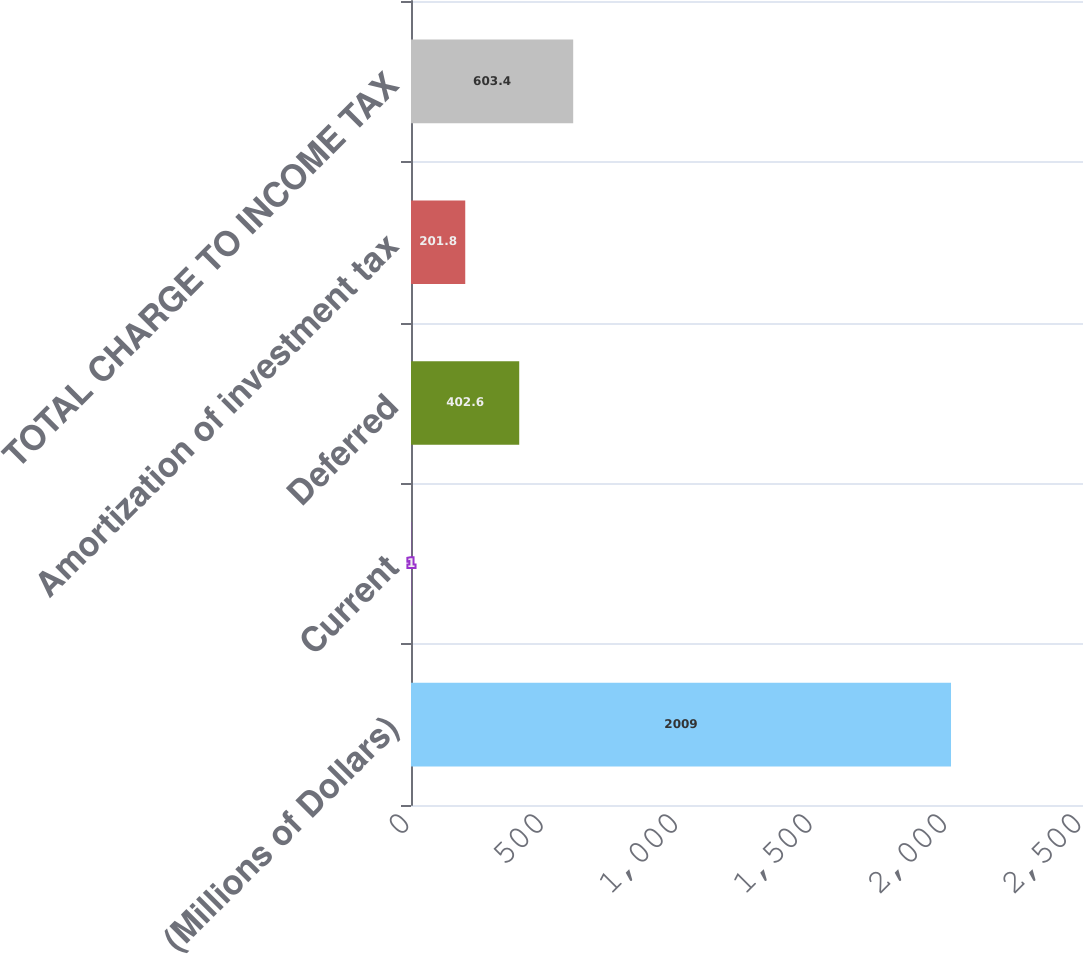<chart> <loc_0><loc_0><loc_500><loc_500><bar_chart><fcel>(Millions of Dollars)<fcel>Current<fcel>Deferred<fcel>Amortization of investment tax<fcel>TOTAL CHARGE TO INCOME TAX<nl><fcel>2009<fcel>1<fcel>402.6<fcel>201.8<fcel>603.4<nl></chart> 